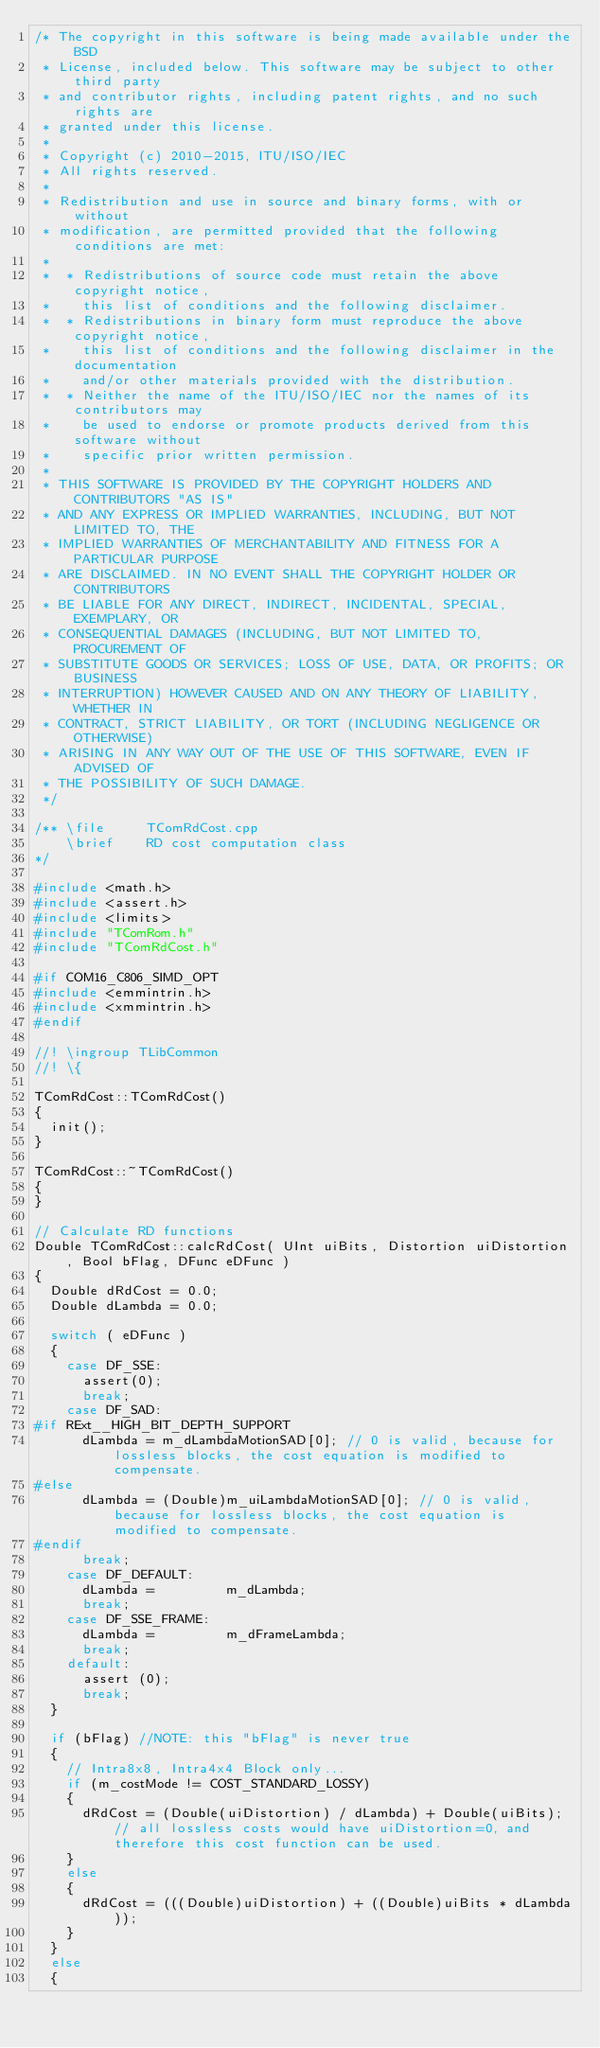<code> <loc_0><loc_0><loc_500><loc_500><_C++_>/* The copyright in this software is being made available under the BSD
 * License, included below. This software may be subject to other third party
 * and contributor rights, including patent rights, and no such rights are
 * granted under this license.
 *
 * Copyright (c) 2010-2015, ITU/ISO/IEC
 * All rights reserved.
 *
 * Redistribution and use in source and binary forms, with or without
 * modification, are permitted provided that the following conditions are met:
 *
 *  * Redistributions of source code must retain the above copyright notice,
 *    this list of conditions and the following disclaimer.
 *  * Redistributions in binary form must reproduce the above copyright notice,
 *    this list of conditions and the following disclaimer in the documentation
 *    and/or other materials provided with the distribution.
 *  * Neither the name of the ITU/ISO/IEC nor the names of its contributors may
 *    be used to endorse or promote products derived from this software without
 *    specific prior written permission.
 *
 * THIS SOFTWARE IS PROVIDED BY THE COPYRIGHT HOLDERS AND CONTRIBUTORS "AS IS"
 * AND ANY EXPRESS OR IMPLIED WARRANTIES, INCLUDING, BUT NOT LIMITED TO, THE
 * IMPLIED WARRANTIES OF MERCHANTABILITY AND FITNESS FOR A PARTICULAR PURPOSE
 * ARE DISCLAIMED. IN NO EVENT SHALL THE COPYRIGHT HOLDER OR CONTRIBUTORS
 * BE LIABLE FOR ANY DIRECT, INDIRECT, INCIDENTAL, SPECIAL, EXEMPLARY, OR
 * CONSEQUENTIAL DAMAGES (INCLUDING, BUT NOT LIMITED TO, PROCUREMENT OF
 * SUBSTITUTE GOODS OR SERVICES; LOSS OF USE, DATA, OR PROFITS; OR BUSINESS
 * INTERRUPTION) HOWEVER CAUSED AND ON ANY THEORY OF LIABILITY, WHETHER IN
 * CONTRACT, STRICT LIABILITY, OR TORT (INCLUDING NEGLIGENCE OR OTHERWISE)
 * ARISING IN ANY WAY OUT OF THE USE OF THIS SOFTWARE, EVEN IF ADVISED OF
 * THE POSSIBILITY OF SUCH DAMAGE.
 */

/** \file     TComRdCost.cpp
    \brief    RD cost computation class
*/

#include <math.h>
#include <assert.h>
#include <limits>
#include "TComRom.h"
#include "TComRdCost.h"

#if COM16_C806_SIMD_OPT
#include <emmintrin.h>  
#include <xmmintrin.h>
#endif

//! \ingroup TLibCommon
//! \{

TComRdCost::TComRdCost()
{
  init();
}

TComRdCost::~TComRdCost()
{
}

// Calculate RD functions
Double TComRdCost::calcRdCost( UInt uiBits, Distortion uiDistortion, Bool bFlag, DFunc eDFunc )
{
  Double dRdCost = 0.0;
  Double dLambda = 0.0;

  switch ( eDFunc )
  {
    case DF_SSE:
      assert(0);
      break;
    case DF_SAD:
#if RExt__HIGH_BIT_DEPTH_SUPPORT
      dLambda = m_dLambdaMotionSAD[0]; // 0 is valid, because for lossless blocks, the cost equation is modified to compensate.
#else
      dLambda = (Double)m_uiLambdaMotionSAD[0]; // 0 is valid, because for lossless blocks, the cost equation is modified to compensate.
#endif
      break;
    case DF_DEFAULT:
      dLambda =         m_dLambda;
      break;
    case DF_SSE_FRAME:
      dLambda =         m_dFrameLambda;
      break;
    default:
      assert (0);
      break;
  }

  if (bFlag) //NOTE: this "bFlag" is never true
  {
    // Intra8x8, Intra4x4 Block only...
    if (m_costMode != COST_STANDARD_LOSSY)
    {
      dRdCost = (Double(uiDistortion) / dLambda) + Double(uiBits); // all lossless costs would have uiDistortion=0, and therefore this cost function can be used.
    }
    else
    {
      dRdCost = (((Double)uiDistortion) + ((Double)uiBits * dLambda));
    }
  }
  else
  {</code> 